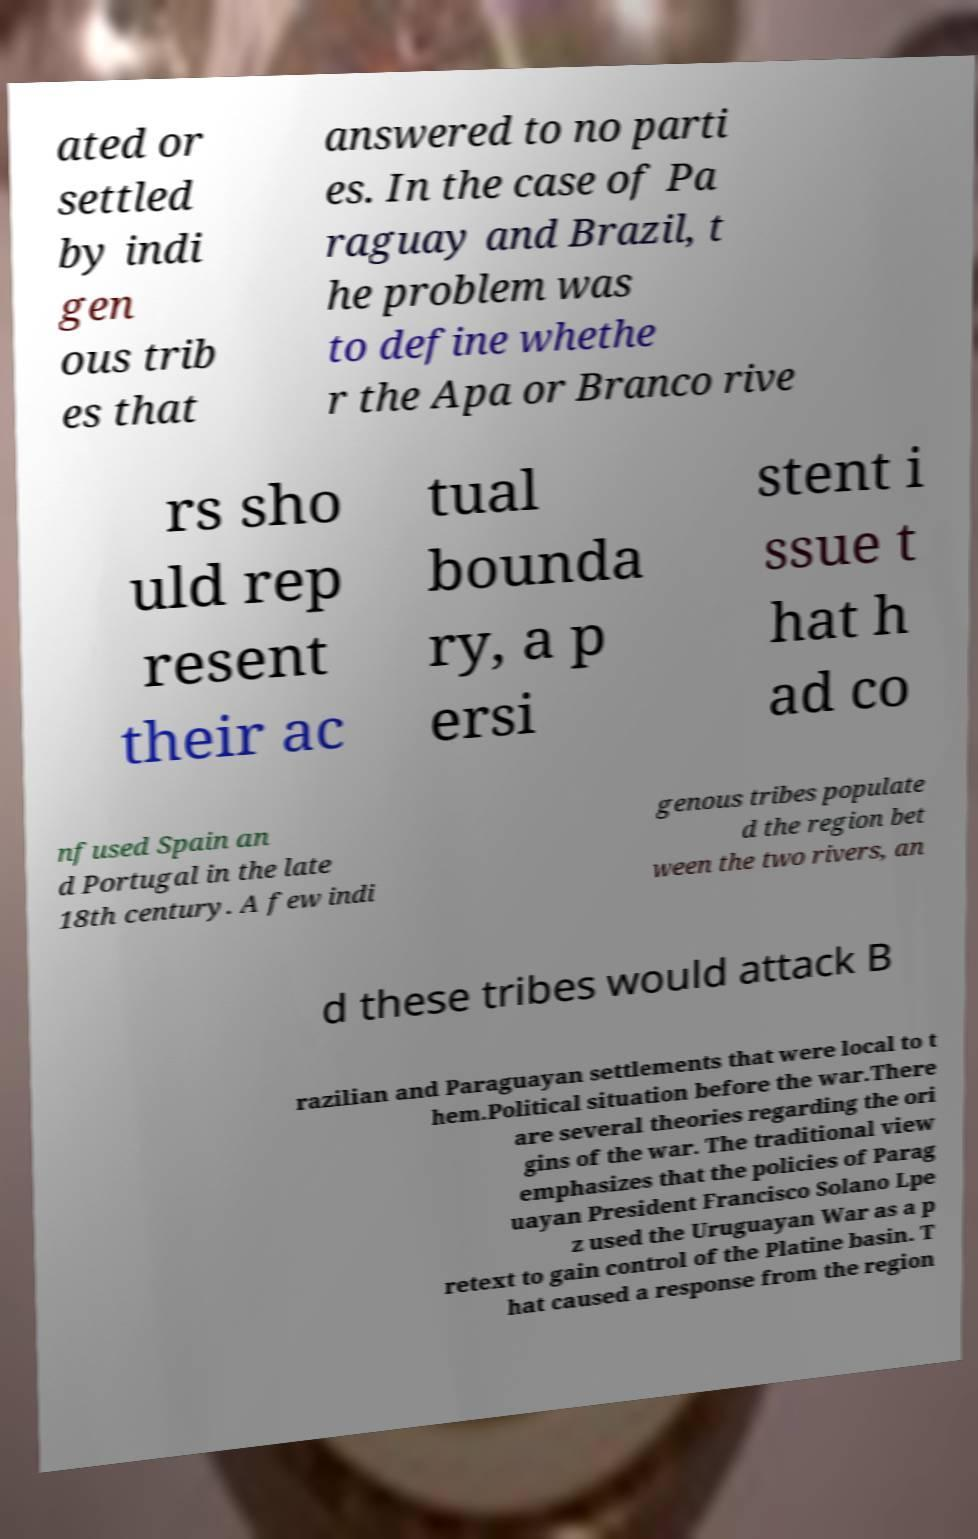Please identify and transcribe the text found in this image. ated or settled by indi gen ous trib es that answered to no parti es. In the case of Pa raguay and Brazil, t he problem was to define whethe r the Apa or Branco rive rs sho uld rep resent their ac tual bounda ry, a p ersi stent i ssue t hat h ad co nfused Spain an d Portugal in the late 18th century. A few indi genous tribes populate d the region bet ween the two rivers, an d these tribes would attack B razilian and Paraguayan settlements that were local to t hem.Political situation before the war.There are several theories regarding the ori gins of the war. The traditional view emphasizes that the policies of Parag uayan President Francisco Solano Lpe z used the Uruguayan War as a p retext to gain control of the Platine basin. T hat caused a response from the region 